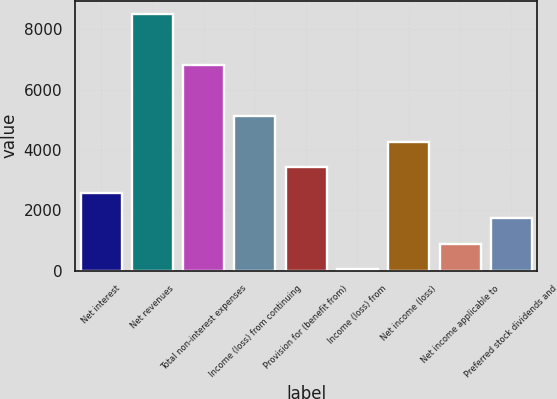Convert chart to OTSL. <chart><loc_0><loc_0><loc_500><loc_500><bar_chart><fcel>Net interest<fcel>Net revenues<fcel>Total non-interest expenses<fcel>Income (loss) from continuing<fcel>Provision for (benefit from)<fcel>Income (loss) from<fcel>Net income (loss)<fcel>Net income applicable to<fcel>Preferred stock dividends and<nl><fcel>2585.4<fcel>8520<fcel>6824.4<fcel>5128.8<fcel>3433.2<fcel>42<fcel>4281<fcel>889.8<fcel>1737.6<nl></chart> 